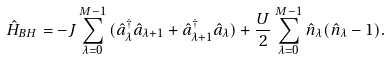Convert formula to latex. <formula><loc_0><loc_0><loc_500><loc_500>\hat { H } _ { B H } = - J \sum _ { \lambda = 0 } ^ { M - 1 } { ( \hat { a } _ { \lambda } ^ { \dagger } \hat { a } _ { \lambda + 1 } + \hat { a } _ { \lambda + 1 } ^ { \dagger } \hat { a } _ { \lambda } ) } + \frac { U } { 2 } \sum _ { \lambda = 0 } ^ { M - 1 } { \hat { n } _ { \lambda } ( \hat { n } _ { \lambda } - 1 ) } .</formula> 